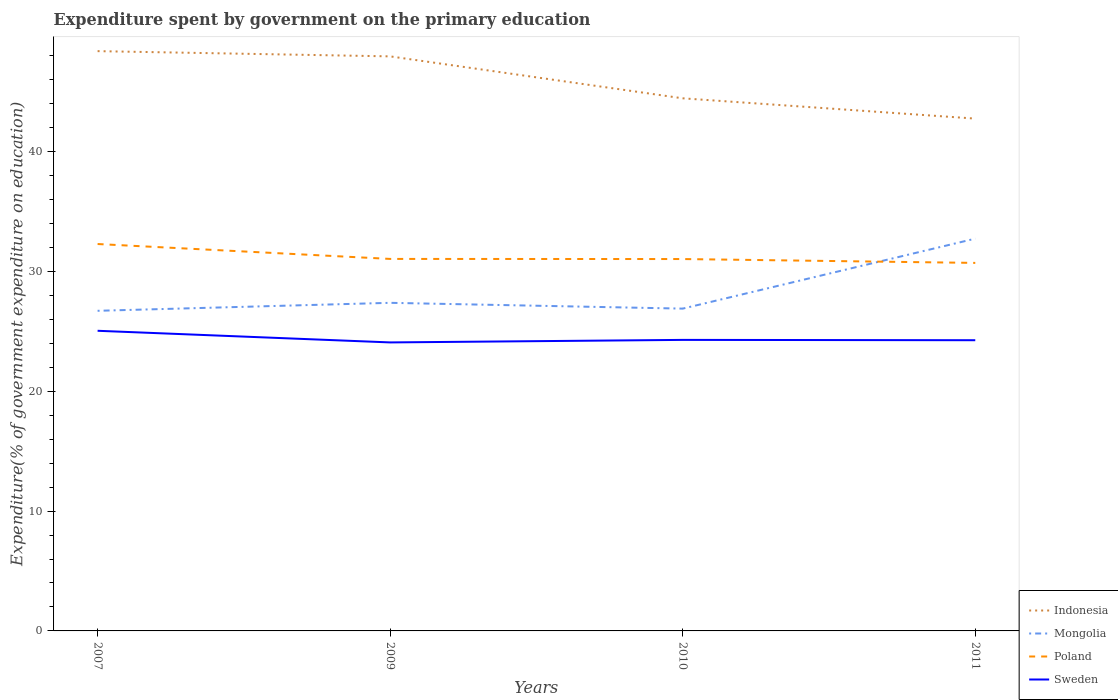How many different coloured lines are there?
Offer a terse response. 4. Is the number of lines equal to the number of legend labels?
Provide a succinct answer. Yes. Across all years, what is the maximum expenditure spent by government on the primary education in Mongolia?
Offer a terse response. 26.71. What is the total expenditure spent by government on the primary education in Sweden in the graph?
Keep it short and to the point. 0.03. What is the difference between the highest and the second highest expenditure spent by government on the primary education in Poland?
Ensure brevity in your answer.  1.58. What is the difference between the highest and the lowest expenditure spent by government on the primary education in Sweden?
Offer a very short reply. 1. How many lines are there?
Your answer should be very brief. 4. What is the difference between two consecutive major ticks on the Y-axis?
Provide a succinct answer. 10. Does the graph contain any zero values?
Ensure brevity in your answer.  No. Where does the legend appear in the graph?
Your response must be concise. Bottom right. What is the title of the graph?
Your answer should be very brief. Expenditure spent by government on the primary education. Does "Niger" appear as one of the legend labels in the graph?
Make the answer very short. No. What is the label or title of the X-axis?
Offer a terse response. Years. What is the label or title of the Y-axis?
Ensure brevity in your answer.  Expenditure(% of government expenditure on education). What is the Expenditure(% of government expenditure on education) in Indonesia in 2007?
Keep it short and to the point. 48.38. What is the Expenditure(% of government expenditure on education) in Mongolia in 2007?
Make the answer very short. 26.71. What is the Expenditure(% of government expenditure on education) of Poland in 2007?
Make the answer very short. 32.29. What is the Expenditure(% of government expenditure on education) in Sweden in 2007?
Your response must be concise. 25.05. What is the Expenditure(% of government expenditure on education) of Indonesia in 2009?
Your response must be concise. 47.95. What is the Expenditure(% of government expenditure on education) of Mongolia in 2009?
Your answer should be very brief. 27.38. What is the Expenditure(% of government expenditure on education) in Poland in 2009?
Provide a succinct answer. 31.04. What is the Expenditure(% of government expenditure on education) of Sweden in 2009?
Your answer should be compact. 24.07. What is the Expenditure(% of government expenditure on education) of Indonesia in 2010?
Offer a very short reply. 44.45. What is the Expenditure(% of government expenditure on education) in Mongolia in 2010?
Provide a succinct answer. 26.9. What is the Expenditure(% of government expenditure on education) in Poland in 2010?
Keep it short and to the point. 31.03. What is the Expenditure(% of government expenditure on education) in Sweden in 2010?
Make the answer very short. 24.29. What is the Expenditure(% of government expenditure on education) in Indonesia in 2011?
Offer a terse response. 42.75. What is the Expenditure(% of government expenditure on education) of Mongolia in 2011?
Ensure brevity in your answer.  32.74. What is the Expenditure(% of government expenditure on education) of Poland in 2011?
Provide a succinct answer. 30.71. What is the Expenditure(% of government expenditure on education) of Sweden in 2011?
Ensure brevity in your answer.  24.26. Across all years, what is the maximum Expenditure(% of government expenditure on education) of Indonesia?
Your answer should be very brief. 48.38. Across all years, what is the maximum Expenditure(% of government expenditure on education) of Mongolia?
Offer a very short reply. 32.74. Across all years, what is the maximum Expenditure(% of government expenditure on education) in Poland?
Keep it short and to the point. 32.29. Across all years, what is the maximum Expenditure(% of government expenditure on education) in Sweden?
Provide a succinct answer. 25.05. Across all years, what is the minimum Expenditure(% of government expenditure on education) of Indonesia?
Your answer should be compact. 42.75. Across all years, what is the minimum Expenditure(% of government expenditure on education) of Mongolia?
Keep it short and to the point. 26.71. Across all years, what is the minimum Expenditure(% of government expenditure on education) in Poland?
Provide a short and direct response. 30.71. Across all years, what is the minimum Expenditure(% of government expenditure on education) of Sweden?
Offer a very short reply. 24.07. What is the total Expenditure(% of government expenditure on education) in Indonesia in the graph?
Make the answer very short. 183.53. What is the total Expenditure(% of government expenditure on education) of Mongolia in the graph?
Offer a very short reply. 113.73. What is the total Expenditure(% of government expenditure on education) of Poland in the graph?
Make the answer very short. 125.07. What is the total Expenditure(% of government expenditure on education) of Sweden in the graph?
Your answer should be very brief. 97.67. What is the difference between the Expenditure(% of government expenditure on education) in Indonesia in 2007 and that in 2009?
Provide a short and direct response. 0.44. What is the difference between the Expenditure(% of government expenditure on education) of Mongolia in 2007 and that in 2009?
Make the answer very short. -0.67. What is the difference between the Expenditure(% of government expenditure on education) in Poland in 2007 and that in 2009?
Offer a very short reply. 1.24. What is the difference between the Expenditure(% of government expenditure on education) in Sweden in 2007 and that in 2009?
Keep it short and to the point. 0.97. What is the difference between the Expenditure(% of government expenditure on education) in Indonesia in 2007 and that in 2010?
Your response must be concise. 3.94. What is the difference between the Expenditure(% of government expenditure on education) of Mongolia in 2007 and that in 2010?
Provide a succinct answer. -0.18. What is the difference between the Expenditure(% of government expenditure on education) in Poland in 2007 and that in 2010?
Your response must be concise. 1.25. What is the difference between the Expenditure(% of government expenditure on education) of Sweden in 2007 and that in 2010?
Make the answer very short. 0.76. What is the difference between the Expenditure(% of government expenditure on education) in Indonesia in 2007 and that in 2011?
Provide a succinct answer. 5.63. What is the difference between the Expenditure(% of government expenditure on education) of Mongolia in 2007 and that in 2011?
Your answer should be compact. -6.02. What is the difference between the Expenditure(% of government expenditure on education) in Poland in 2007 and that in 2011?
Ensure brevity in your answer.  1.58. What is the difference between the Expenditure(% of government expenditure on education) of Sweden in 2007 and that in 2011?
Your answer should be compact. 0.79. What is the difference between the Expenditure(% of government expenditure on education) of Indonesia in 2009 and that in 2010?
Keep it short and to the point. 3.5. What is the difference between the Expenditure(% of government expenditure on education) in Mongolia in 2009 and that in 2010?
Provide a short and direct response. 0.48. What is the difference between the Expenditure(% of government expenditure on education) in Poland in 2009 and that in 2010?
Keep it short and to the point. 0.01. What is the difference between the Expenditure(% of government expenditure on education) of Sweden in 2009 and that in 2010?
Provide a succinct answer. -0.21. What is the difference between the Expenditure(% of government expenditure on education) in Indonesia in 2009 and that in 2011?
Your answer should be compact. 5.19. What is the difference between the Expenditure(% of government expenditure on education) in Mongolia in 2009 and that in 2011?
Your response must be concise. -5.36. What is the difference between the Expenditure(% of government expenditure on education) of Poland in 2009 and that in 2011?
Keep it short and to the point. 0.33. What is the difference between the Expenditure(% of government expenditure on education) in Sweden in 2009 and that in 2011?
Provide a succinct answer. -0.18. What is the difference between the Expenditure(% of government expenditure on education) in Indonesia in 2010 and that in 2011?
Give a very brief answer. 1.69. What is the difference between the Expenditure(% of government expenditure on education) in Mongolia in 2010 and that in 2011?
Your answer should be very brief. -5.84. What is the difference between the Expenditure(% of government expenditure on education) of Poland in 2010 and that in 2011?
Your response must be concise. 0.32. What is the difference between the Expenditure(% of government expenditure on education) in Sweden in 2010 and that in 2011?
Provide a succinct answer. 0.03. What is the difference between the Expenditure(% of government expenditure on education) in Indonesia in 2007 and the Expenditure(% of government expenditure on education) in Mongolia in 2009?
Provide a short and direct response. 21. What is the difference between the Expenditure(% of government expenditure on education) in Indonesia in 2007 and the Expenditure(% of government expenditure on education) in Poland in 2009?
Provide a succinct answer. 17.34. What is the difference between the Expenditure(% of government expenditure on education) in Indonesia in 2007 and the Expenditure(% of government expenditure on education) in Sweden in 2009?
Make the answer very short. 24.31. What is the difference between the Expenditure(% of government expenditure on education) in Mongolia in 2007 and the Expenditure(% of government expenditure on education) in Poland in 2009?
Offer a very short reply. -4.33. What is the difference between the Expenditure(% of government expenditure on education) in Mongolia in 2007 and the Expenditure(% of government expenditure on education) in Sweden in 2009?
Ensure brevity in your answer.  2.64. What is the difference between the Expenditure(% of government expenditure on education) of Poland in 2007 and the Expenditure(% of government expenditure on education) of Sweden in 2009?
Offer a very short reply. 8.21. What is the difference between the Expenditure(% of government expenditure on education) in Indonesia in 2007 and the Expenditure(% of government expenditure on education) in Mongolia in 2010?
Provide a short and direct response. 21.49. What is the difference between the Expenditure(% of government expenditure on education) of Indonesia in 2007 and the Expenditure(% of government expenditure on education) of Poland in 2010?
Offer a terse response. 17.35. What is the difference between the Expenditure(% of government expenditure on education) of Indonesia in 2007 and the Expenditure(% of government expenditure on education) of Sweden in 2010?
Make the answer very short. 24.1. What is the difference between the Expenditure(% of government expenditure on education) in Mongolia in 2007 and the Expenditure(% of government expenditure on education) in Poland in 2010?
Provide a short and direct response. -4.32. What is the difference between the Expenditure(% of government expenditure on education) in Mongolia in 2007 and the Expenditure(% of government expenditure on education) in Sweden in 2010?
Offer a terse response. 2.43. What is the difference between the Expenditure(% of government expenditure on education) in Poland in 2007 and the Expenditure(% of government expenditure on education) in Sweden in 2010?
Offer a terse response. 8. What is the difference between the Expenditure(% of government expenditure on education) in Indonesia in 2007 and the Expenditure(% of government expenditure on education) in Mongolia in 2011?
Your answer should be compact. 15.65. What is the difference between the Expenditure(% of government expenditure on education) in Indonesia in 2007 and the Expenditure(% of government expenditure on education) in Poland in 2011?
Offer a terse response. 17.67. What is the difference between the Expenditure(% of government expenditure on education) in Indonesia in 2007 and the Expenditure(% of government expenditure on education) in Sweden in 2011?
Keep it short and to the point. 24.12. What is the difference between the Expenditure(% of government expenditure on education) of Mongolia in 2007 and the Expenditure(% of government expenditure on education) of Poland in 2011?
Offer a terse response. -4. What is the difference between the Expenditure(% of government expenditure on education) in Mongolia in 2007 and the Expenditure(% of government expenditure on education) in Sweden in 2011?
Your answer should be very brief. 2.45. What is the difference between the Expenditure(% of government expenditure on education) of Poland in 2007 and the Expenditure(% of government expenditure on education) of Sweden in 2011?
Ensure brevity in your answer.  8.03. What is the difference between the Expenditure(% of government expenditure on education) in Indonesia in 2009 and the Expenditure(% of government expenditure on education) in Mongolia in 2010?
Provide a short and direct response. 21.05. What is the difference between the Expenditure(% of government expenditure on education) of Indonesia in 2009 and the Expenditure(% of government expenditure on education) of Poland in 2010?
Your response must be concise. 16.91. What is the difference between the Expenditure(% of government expenditure on education) in Indonesia in 2009 and the Expenditure(% of government expenditure on education) in Sweden in 2010?
Provide a short and direct response. 23.66. What is the difference between the Expenditure(% of government expenditure on education) of Mongolia in 2009 and the Expenditure(% of government expenditure on education) of Poland in 2010?
Your answer should be compact. -3.65. What is the difference between the Expenditure(% of government expenditure on education) of Mongolia in 2009 and the Expenditure(% of government expenditure on education) of Sweden in 2010?
Make the answer very short. 3.09. What is the difference between the Expenditure(% of government expenditure on education) of Poland in 2009 and the Expenditure(% of government expenditure on education) of Sweden in 2010?
Provide a succinct answer. 6.76. What is the difference between the Expenditure(% of government expenditure on education) in Indonesia in 2009 and the Expenditure(% of government expenditure on education) in Mongolia in 2011?
Your response must be concise. 15.21. What is the difference between the Expenditure(% of government expenditure on education) in Indonesia in 2009 and the Expenditure(% of government expenditure on education) in Poland in 2011?
Keep it short and to the point. 17.24. What is the difference between the Expenditure(% of government expenditure on education) of Indonesia in 2009 and the Expenditure(% of government expenditure on education) of Sweden in 2011?
Offer a very short reply. 23.69. What is the difference between the Expenditure(% of government expenditure on education) of Mongolia in 2009 and the Expenditure(% of government expenditure on education) of Poland in 2011?
Provide a succinct answer. -3.33. What is the difference between the Expenditure(% of government expenditure on education) of Mongolia in 2009 and the Expenditure(% of government expenditure on education) of Sweden in 2011?
Your response must be concise. 3.12. What is the difference between the Expenditure(% of government expenditure on education) of Poland in 2009 and the Expenditure(% of government expenditure on education) of Sweden in 2011?
Give a very brief answer. 6.78. What is the difference between the Expenditure(% of government expenditure on education) in Indonesia in 2010 and the Expenditure(% of government expenditure on education) in Mongolia in 2011?
Keep it short and to the point. 11.71. What is the difference between the Expenditure(% of government expenditure on education) of Indonesia in 2010 and the Expenditure(% of government expenditure on education) of Poland in 2011?
Ensure brevity in your answer.  13.74. What is the difference between the Expenditure(% of government expenditure on education) in Indonesia in 2010 and the Expenditure(% of government expenditure on education) in Sweden in 2011?
Keep it short and to the point. 20.19. What is the difference between the Expenditure(% of government expenditure on education) in Mongolia in 2010 and the Expenditure(% of government expenditure on education) in Poland in 2011?
Keep it short and to the point. -3.81. What is the difference between the Expenditure(% of government expenditure on education) in Mongolia in 2010 and the Expenditure(% of government expenditure on education) in Sweden in 2011?
Keep it short and to the point. 2.64. What is the difference between the Expenditure(% of government expenditure on education) in Poland in 2010 and the Expenditure(% of government expenditure on education) in Sweden in 2011?
Your response must be concise. 6.77. What is the average Expenditure(% of government expenditure on education) in Indonesia per year?
Your answer should be compact. 45.88. What is the average Expenditure(% of government expenditure on education) in Mongolia per year?
Give a very brief answer. 28.43. What is the average Expenditure(% of government expenditure on education) of Poland per year?
Your response must be concise. 31.27. What is the average Expenditure(% of government expenditure on education) in Sweden per year?
Give a very brief answer. 24.42. In the year 2007, what is the difference between the Expenditure(% of government expenditure on education) in Indonesia and Expenditure(% of government expenditure on education) in Mongolia?
Give a very brief answer. 21.67. In the year 2007, what is the difference between the Expenditure(% of government expenditure on education) in Indonesia and Expenditure(% of government expenditure on education) in Poland?
Provide a short and direct response. 16.1. In the year 2007, what is the difference between the Expenditure(% of government expenditure on education) in Indonesia and Expenditure(% of government expenditure on education) in Sweden?
Your answer should be very brief. 23.34. In the year 2007, what is the difference between the Expenditure(% of government expenditure on education) in Mongolia and Expenditure(% of government expenditure on education) in Poland?
Your answer should be compact. -5.57. In the year 2007, what is the difference between the Expenditure(% of government expenditure on education) in Mongolia and Expenditure(% of government expenditure on education) in Sweden?
Offer a terse response. 1.67. In the year 2007, what is the difference between the Expenditure(% of government expenditure on education) in Poland and Expenditure(% of government expenditure on education) in Sweden?
Your answer should be compact. 7.24. In the year 2009, what is the difference between the Expenditure(% of government expenditure on education) of Indonesia and Expenditure(% of government expenditure on education) of Mongolia?
Your response must be concise. 20.57. In the year 2009, what is the difference between the Expenditure(% of government expenditure on education) in Indonesia and Expenditure(% of government expenditure on education) in Poland?
Your response must be concise. 16.9. In the year 2009, what is the difference between the Expenditure(% of government expenditure on education) in Indonesia and Expenditure(% of government expenditure on education) in Sweden?
Your response must be concise. 23.87. In the year 2009, what is the difference between the Expenditure(% of government expenditure on education) of Mongolia and Expenditure(% of government expenditure on education) of Poland?
Keep it short and to the point. -3.66. In the year 2009, what is the difference between the Expenditure(% of government expenditure on education) of Mongolia and Expenditure(% of government expenditure on education) of Sweden?
Ensure brevity in your answer.  3.3. In the year 2009, what is the difference between the Expenditure(% of government expenditure on education) of Poland and Expenditure(% of government expenditure on education) of Sweden?
Provide a succinct answer. 6.97. In the year 2010, what is the difference between the Expenditure(% of government expenditure on education) of Indonesia and Expenditure(% of government expenditure on education) of Mongolia?
Your answer should be compact. 17.55. In the year 2010, what is the difference between the Expenditure(% of government expenditure on education) of Indonesia and Expenditure(% of government expenditure on education) of Poland?
Your answer should be compact. 13.41. In the year 2010, what is the difference between the Expenditure(% of government expenditure on education) in Indonesia and Expenditure(% of government expenditure on education) in Sweden?
Keep it short and to the point. 20.16. In the year 2010, what is the difference between the Expenditure(% of government expenditure on education) in Mongolia and Expenditure(% of government expenditure on education) in Poland?
Make the answer very short. -4.14. In the year 2010, what is the difference between the Expenditure(% of government expenditure on education) of Mongolia and Expenditure(% of government expenditure on education) of Sweden?
Your answer should be compact. 2.61. In the year 2010, what is the difference between the Expenditure(% of government expenditure on education) of Poland and Expenditure(% of government expenditure on education) of Sweden?
Your answer should be compact. 6.75. In the year 2011, what is the difference between the Expenditure(% of government expenditure on education) in Indonesia and Expenditure(% of government expenditure on education) in Mongolia?
Give a very brief answer. 10.02. In the year 2011, what is the difference between the Expenditure(% of government expenditure on education) of Indonesia and Expenditure(% of government expenditure on education) of Poland?
Offer a terse response. 12.04. In the year 2011, what is the difference between the Expenditure(% of government expenditure on education) in Indonesia and Expenditure(% of government expenditure on education) in Sweden?
Ensure brevity in your answer.  18.49. In the year 2011, what is the difference between the Expenditure(% of government expenditure on education) in Mongolia and Expenditure(% of government expenditure on education) in Poland?
Your response must be concise. 2.03. In the year 2011, what is the difference between the Expenditure(% of government expenditure on education) of Mongolia and Expenditure(% of government expenditure on education) of Sweden?
Offer a terse response. 8.48. In the year 2011, what is the difference between the Expenditure(% of government expenditure on education) of Poland and Expenditure(% of government expenditure on education) of Sweden?
Give a very brief answer. 6.45. What is the ratio of the Expenditure(% of government expenditure on education) in Indonesia in 2007 to that in 2009?
Your response must be concise. 1.01. What is the ratio of the Expenditure(% of government expenditure on education) in Mongolia in 2007 to that in 2009?
Provide a succinct answer. 0.98. What is the ratio of the Expenditure(% of government expenditure on education) of Poland in 2007 to that in 2009?
Give a very brief answer. 1.04. What is the ratio of the Expenditure(% of government expenditure on education) of Sweden in 2007 to that in 2009?
Your answer should be compact. 1.04. What is the ratio of the Expenditure(% of government expenditure on education) of Indonesia in 2007 to that in 2010?
Give a very brief answer. 1.09. What is the ratio of the Expenditure(% of government expenditure on education) in Mongolia in 2007 to that in 2010?
Ensure brevity in your answer.  0.99. What is the ratio of the Expenditure(% of government expenditure on education) in Poland in 2007 to that in 2010?
Give a very brief answer. 1.04. What is the ratio of the Expenditure(% of government expenditure on education) in Sweden in 2007 to that in 2010?
Keep it short and to the point. 1.03. What is the ratio of the Expenditure(% of government expenditure on education) in Indonesia in 2007 to that in 2011?
Give a very brief answer. 1.13. What is the ratio of the Expenditure(% of government expenditure on education) in Mongolia in 2007 to that in 2011?
Your answer should be compact. 0.82. What is the ratio of the Expenditure(% of government expenditure on education) in Poland in 2007 to that in 2011?
Ensure brevity in your answer.  1.05. What is the ratio of the Expenditure(% of government expenditure on education) in Sweden in 2007 to that in 2011?
Give a very brief answer. 1.03. What is the ratio of the Expenditure(% of government expenditure on education) of Indonesia in 2009 to that in 2010?
Your answer should be very brief. 1.08. What is the ratio of the Expenditure(% of government expenditure on education) of Mongolia in 2009 to that in 2010?
Make the answer very short. 1.02. What is the ratio of the Expenditure(% of government expenditure on education) of Sweden in 2009 to that in 2010?
Provide a succinct answer. 0.99. What is the ratio of the Expenditure(% of government expenditure on education) in Indonesia in 2009 to that in 2011?
Your answer should be compact. 1.12. What is the ratio of the Expenditure(% of government expenditure on education) in Mongolia in 2009 to that in 2011?
Give a very brief answer. 0.84. What is the ratio of the Expenditure(% of government expenditure on education) of Poland in 2009 to that in 2011?
Make the answer very short. 1.01. What is the ratio of the Expenditure(% of government expenditure on education) of Indonesia in 2010 to that in 2011?
Ensure brevity in your answer.  1.04. What is the ratio of the Expenditure(% of government expenditure on education) in Mongolia in 2010 to that in 2011?
Give a very brief answer. 0.82. What is the ratio of the Expenditure(% of government expenditure on education) in Poland in 2010 to that in 2011?
Provide a short and direct response. 1.01. What is the difference between the highest and the second highest Expenditure(% of government expenditure on education) in Indonesia?
Give a very brief answer. 0.44. What is the difference between the highest and the second highest Expenditure(% of government expenditure on education) in Mongolia?
Your answer should be very brief. 5.36. What is the difference between the highest and the second highest Expenditure(% of government expenditure on education) in Poland?
Provide a short and direct response. 1.24. What is the difference between the highest and the second highest Expenditure(% of government expenditure on education) of Sweden?
Offer a terse response. 0.76. What is the difference between the highest and the lowest Expenditure(% of government expenditure on education) of Indonesia?
Your answer should be compact. 5.63. What is the difference between the highest and the lowest Expenditure(% of government expenditure on education) of Mongolia?
Offer a terse response. 6.02. What is the difference between the highest and the lowest Expenditure(% of government expenditure on education) of Poland?
Make the answer very short. 1.58. What is the difference between the highest and the lowest Expenditure(% of government expenditure on education) of Sweden?
Provide a short and direct response. 0.97. 